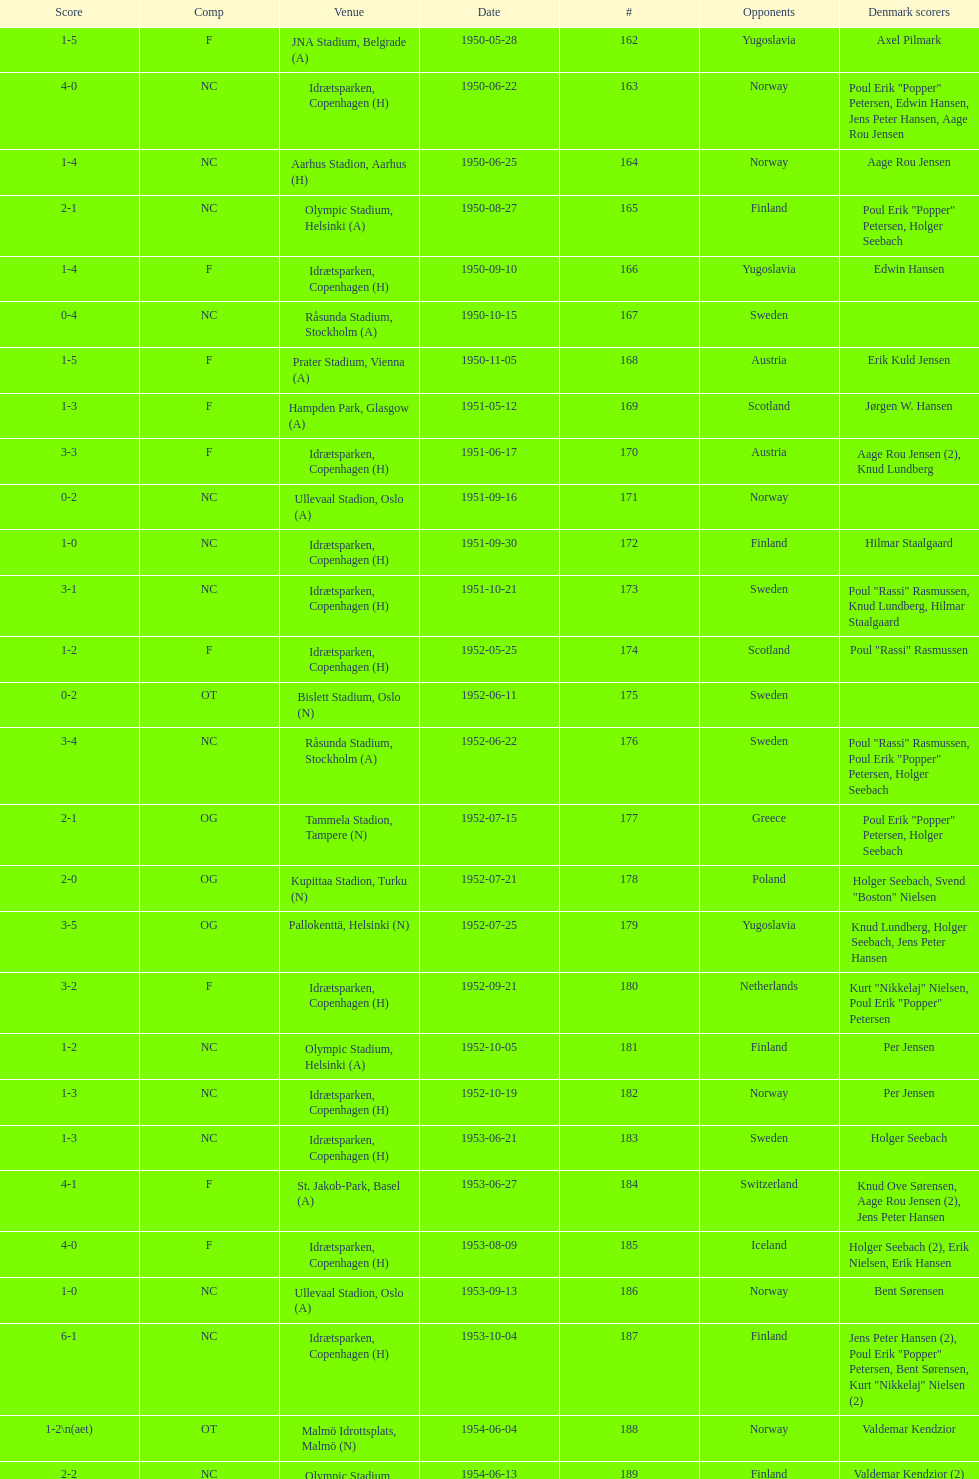Who did they play in the game listed directly above july 25, 1952? Poland. 